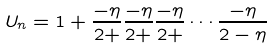<formula> <loc_0><loc_0><loc_500><loc_500>U _ { n } = 1 + \frac { - \eta } { 2 + } \frac { - \eta } { 2 + } \frac { - \eta } { 2 + } \cdots \frac { - \eta } { 2 - \eta }</formula> 